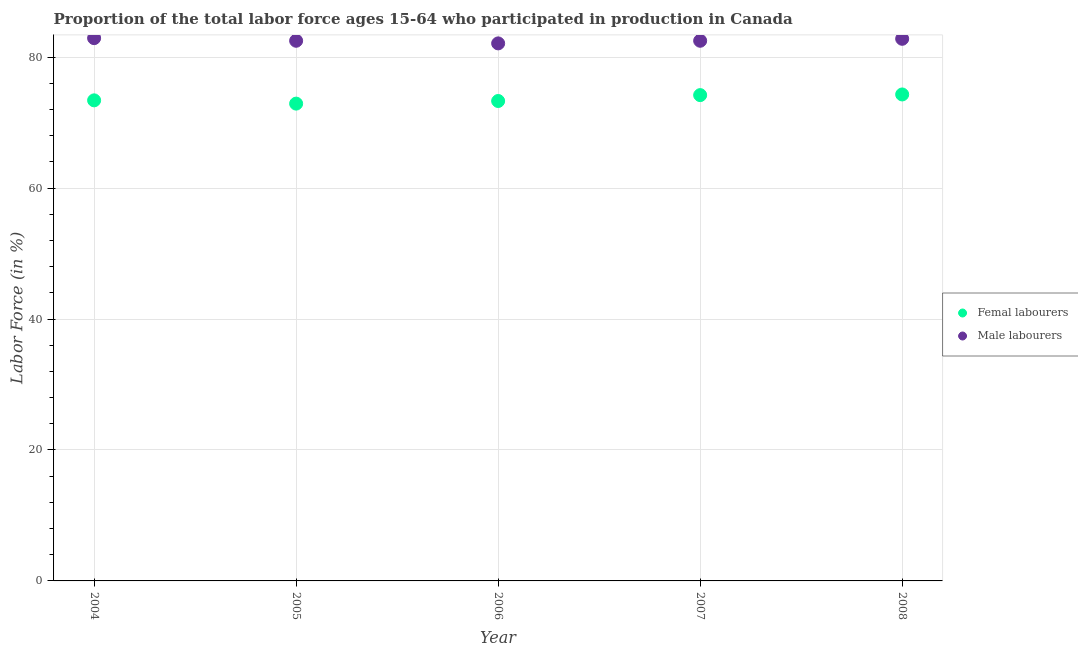Is the number of dotlines equal to the number of legend labels?
Provide a short and direct response. Yes. What is the percentage of male labour force in 2008?
Provide a succinct answer. 82.8. Across all years, what is the maximum percentage of female labor force?
Give a very brief answer. 74.3. Across all years, what is the minimum percentage of female labor force?
Make the answer very short. 72.9. In which year was the percentage of female labor force maximum?
Offer a terse response. 2008. What is the total percentage of female labor force in the graph?
Make the answer very short. 368.1. What is the difference between the percentage of female labor force in 2004 and that in 2007?
Your answer should be very brief. -0.8. What is the difference between the percentage of female labor force in 2007 and the percentage of male labour force in 2005?
Your response must be concise. -8.3. What is the average percentage of male labour force per year?
Your answer should be very brief. 82.56. In the year 2005, what is the difference between the percentage of male labour force and percentage of female labor force?
Your response must be concise. 9.6. In how many years, is the percentage of male labour force greater than 40 %?
Make the answer very short. 5. What is the ratio of the percentage of female labor force in 2005 to that in 2006?
Provide a short and direct response. 0.99. What is the difference between the highest and the second highest percentage of female labor force?
Provide a short and direct response. 0.1. What is the difference between the highest and the lowest percentage of male labour force?
Make the answer very short. 0.8. In how many years, is the percentage of male labour force greater than the average percentage of male labour force taken over all years?
Your response must be concise. 2. Is the sum of the percentage of male labour force in 2006 and 2007 greater than the maximum percentage of female labor force across all years?
Your answer should be compact. Yes. Is the percentage of male labour force strictly less than the percentage of female labor force over the years?
Offer a terse response. No. How many dotlines are there?
Your answer should be very brief. 2. How many years are there in the graph?
Provide a short and direct response. 5. What is the difference between two consecutive major ticks on the Y-axis?
Your answer should be compact. 20. Does the graph contain any zero values?
Make the answer very short. No. Does the graph contain grids?
Provide a succinct answer. Yes. Where does the legend appear in the graph?
Offer a terse response. Center right. How many legend labels are there?
Keep it short and to the point. 2. What is the title of the graph?
Your answer should be very brief. Proportion of the total labor force ages 15-64 who participated in production in Canada. Does "Total Population" appear as one of the legend labels in the graph?
Keep it short and to the point. No. What is the label or title of the X-axis?
Your answer should be compact. Year. What is the Labor Force (in %) of Femal labourers in 2004?
Provide a short and direct response. 73.4. What is the Labor Force (in %) in Male labourers in 2004?
Make the answer very short. 82.9. What is the Labor Force (in %) of Femal labourers in 2005?
Give a very brief answer. 72.9. What is the Labor Force (in %) in Male labourers in 2005?
Ensure brevity in your answer.  82.5. What is the Labor Force (in %) in Femal labourers in 2006?
Give a very brief answer. 73.3. What is the Labor Force (in %) in Male labourers in 2006?
Provide a succinct answer. 82.1. What is the Labor Force (in %) in Femal labourers in 2007?
Keep it short and to the point. 74.2. What is the Labor Force (in %) in Male labourers in 2007?
Make the answer very short. 82.5. What is the Labor Force (in %) in Femal labourers in 2008?
Offer a terse response. 74.3. What is the Labor Force (in %) in Male labourers in 2008?
Give a very brief answer. 82.8. Across all years, what is the maximum Labor Force (in %) in Femal labourers?
Offer a very short reply. 74.3. Across all years, what is the maximum Labor Force (in %) in Male labourers?
Offer a very short reply. 82.9. Across all years, what is the minimum Labor Force (in %) in Femal labourers?
Provide a succinct answer. 72.9. Across all years, what is the minimum Labor Force (in %) in Male labourers?
Your response must be concise. 82.1. What is the total Labor Force (in %) in Femal labourers in the graph?
Keep it short and to the point. 368.1. What is the total Labor Force (in %) in Male labourers in the graph?
Provide a succinct answer. 412.8. What is the difference between the Labor Force (in %) in Femal labourers in 2004 and that in 2005?
Make the answer very short. 0.5. What is the difference between the Labor Force (in %) in Male labourers in 2004 and that in 2005?
Make the answer very short. 0.4. What is the difference between the Labor Force (in %) in Femal labourers in 2004 and that in 2006?
Your response must be concise. 0.1. What is the difference between the Labor Force (in %) in Femal labourers in 2004 and that in 2007?
Your response must be concise. -0.8. What is the difference between the Labor Force (in %) of Male labourers in 2004 and that in 2007?
Offer a very short reply. 0.4. What is the difference between the Labor Force (in %) in Femal labourers in 2004 and that in 2008?
Offer a terse response. -0.9. What is the difference between the Labor Force (in %) in Male labourers in 2004 and that in 2008?
Offer a very short reply. 0.1. What is the difference between the Labor Force (in %) in Femal labourers in 2005 and that in 2006?
Your answer should be very brief. -0.4. What is the difference between the Labor Force (in %) in Male labourers in 2005 and that in 2006?
Provide a short and direct response. 0.4. What is the difference between the Labor Force (in %) in Femal labourers in 2005 and that in 2007?
Provide a succinct answer. -1.3. What is the difference between the Labor Force (in %) of Male labourers in 2005 and that in 2008?
Offer a terse response. -0.3. What is the difference between the Labor Force (in %) in Femal labourers in 2006 and that in 2007?
Your answer should be compact. -0.9. What is the difference between the Labor Force (in %) of Male labourers in 2006 and that in 2007?
Provide a short and direct response. -0.4. What is the difference between the Labor Force (in %) of Male labourers in 2006 and that in 2008?
Ensure brevity in your answer.  -0.7. What is the difference between the Labor Force (in %) of Femal labourers in 2007 and that in 2008?
Give a very brief answer. -0.1. What is the difference between the Labor Force (in %) in Femal labourers in 2004 and the Labor Force (in %) in Male labourers in 2007?
Make the answer very short. -9.1. What is the difference between the Labor Force (in %) of Femal labourers in 2005 and the Labor Force (in %) of Male labourers in 2007?
Offer a very short reply. -9.6. What is the difference between the Labor Force (in %) of Femal labourers in 2007 and the Labor Force (in %) of Male labourers in 2008?
Your answer should be compact. -8.6. What is the average Labor Force (in %) in Femal labourers per year?
Offer a very short reply. 73.62. What is the average Labor Force (in %) of Male labourers per year?
Your answer should be compact. 82.56. In the year 2004, what is the difference between the Labor Force (in %) in Femal labourers and Labor Force (in %) in Male labourers?
Your answer should be compact. -9.5. In the year 2005, what is the difference between the Labor Force (in %) of Femal labourers and Labor Force (in %) of Male labourers?
Provide a succinct answer. -9.6. In the year 2008, what is the difference between the Labor Force (in %) of Femal labourers and Labor Force (in %) of Male labourers?
Provide a short and direct response. -8.5. What is the ratio of the Labor Force (in %) of Femal labourers in 2004 to that in 2005?
Ensure brevity in your answer.  1.01. What is the ratio of the Labor Force (in %) in Femal labourers in 2004 to that in 2006?
Provide a short and direct response. 1. What is the ratio of the Labor Force (in %) in Male labourers in 2004 to that in 2006?
Keep it short and to the point. 1.01. What is the ratio of the Labor Force (in %) of Femal labourers in 2004 to that in 2007?
Your answer should be very brief. 0.99. What is the ratio of the Labor Force (in %) in Femal labourers in 2004 to that in 2008?
Give a very brief answer. 0.99. What is the ratio of the Labor Force (in %) of Femal labourers in 2005 to that in 2006?
Your response must be concise. 0.99. What is the ratio of the Labor Force (in %) in Femal labourers in 2005 to that in 2007?
Keep it short and to the point. 0.98. What is the ratio of the Labor Force (in %) of Male labourers in 2005 to that in 2007?
Make the answer very short. 1. What is the ratio of the Labor Force (in %) in Femal labourers in 2005 to that in 2008?
Your answer should be very brief. 0.98. What is the ratio of the Labor Force (in %) of Male labourers in 2005 to that in 2008?
Make the answer very short. 1. What is the ratio of the Labor Force (in %) in Femal labourers in 2006 to that in 2007?
Make the answer very short. 0.99. What is the ratio of the Labor Force (in %) in Male labourers in 2006 to that in 2007?
Provide a short and direct response. 1. What is the ratio of the Labor Force (in %) in Femal labourers in 2006 to that in 2008?
Your response must be concise. 0.99. What is the ratio of the Labor Force (in %) of Male labourers in 2006 to that in 2008?
Provide a succinct answer. 0.99. What is the ratio of the Labor Force (in %) of Male labourers in 2007 to that in 2008?
Your answer should be very brief. 1. What is the difference between the highest and the second highest Labor Force (in %) in Femal labourers?
Your response must be concise. 0.1. 